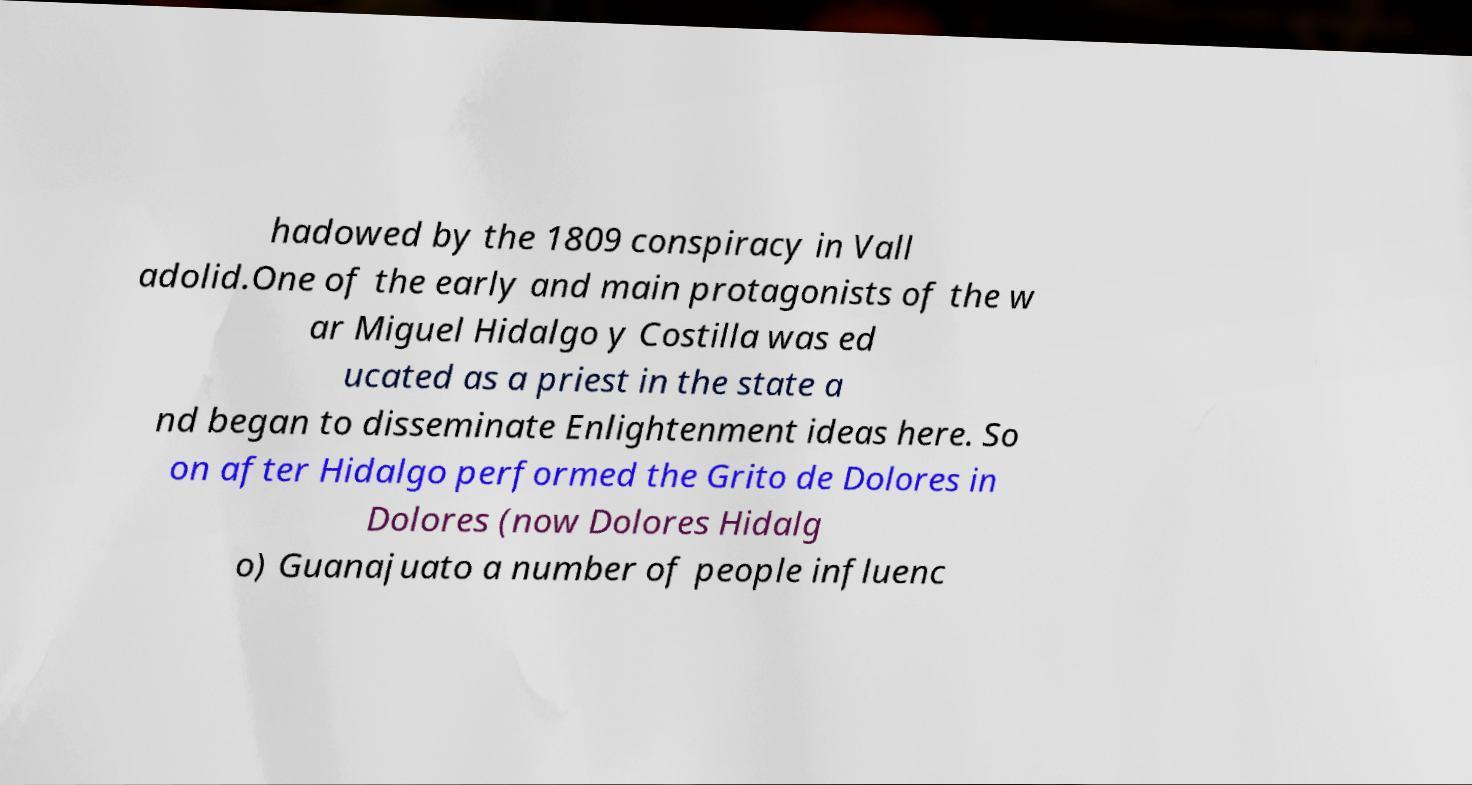There's text embedded in this image that I need extracted. Can you transcribe it verbatim? hadowed by the 1809 conspiracy in Vall adolid.One of the early and main protagonists of the w ar Miguel Hidalgo y Costilla was ed ucated as a priest in the state a nd began to disseminate Enlightenment ideas here. So on after Hidalgo performed the Grito de Dolores in Dolores (now Dolores Hidalg o) Guanajuato a number of people influenc 